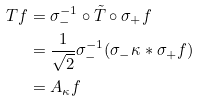Convert formula to latex. <formula><loc_0><loc_0><loc_500><loc_500>T f & = \sigma _ { - } ^ { - 1 } \circ \tilde { T } \circ \sigma _ { + } f \\ & = \frac { 1 } { \sqrt { 2 } } \sigma _ { - } ^ { - 1 } ( \sigma _ { - } \kappa \ast \sigma _ { + } f ) \\ & = A _ { \kappa } f</formula> 